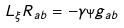Convert formula to latex. <formula><loc_0><loc_0><loc_500><loc_500>L _ { \xi } R _ { a b } = - \gamma _ { \Psi } g _ { a b }</formula> 